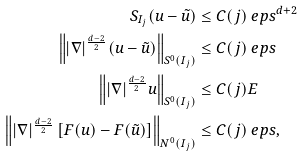Convert formula to latex. <formula><loc_0><loc_0><loc_500><loc_500>S _ { I _ { j } } ( u - \tilde { u } ) & \leq C ( j ) \ e p s ^ { d + 2 } \\ \left \| | \nabla | ^ { \frac { d - 2 } 2 } ( u - \tilde { u } ) \right \| _ { S ^ { 0 } ( I _ { j } ) } & \leq C ( j ) \ e p s \\ \left \| | \nabla | ^ { \frac { d - 2 } 2 } u \right \| _ { S ^ { 0 } ( I _ { j } ) } & \leq C ( j ) E \\ \left \| | \nabla | ^ { \frac { d - 2 } 2 } \left [ F ( u ) - F ( \tilde { u } ) \right ] \right \| _ { N ^ { 0 } ( I _ { j } ) } & \leq C ( j ) \ e p s ,</formula> 